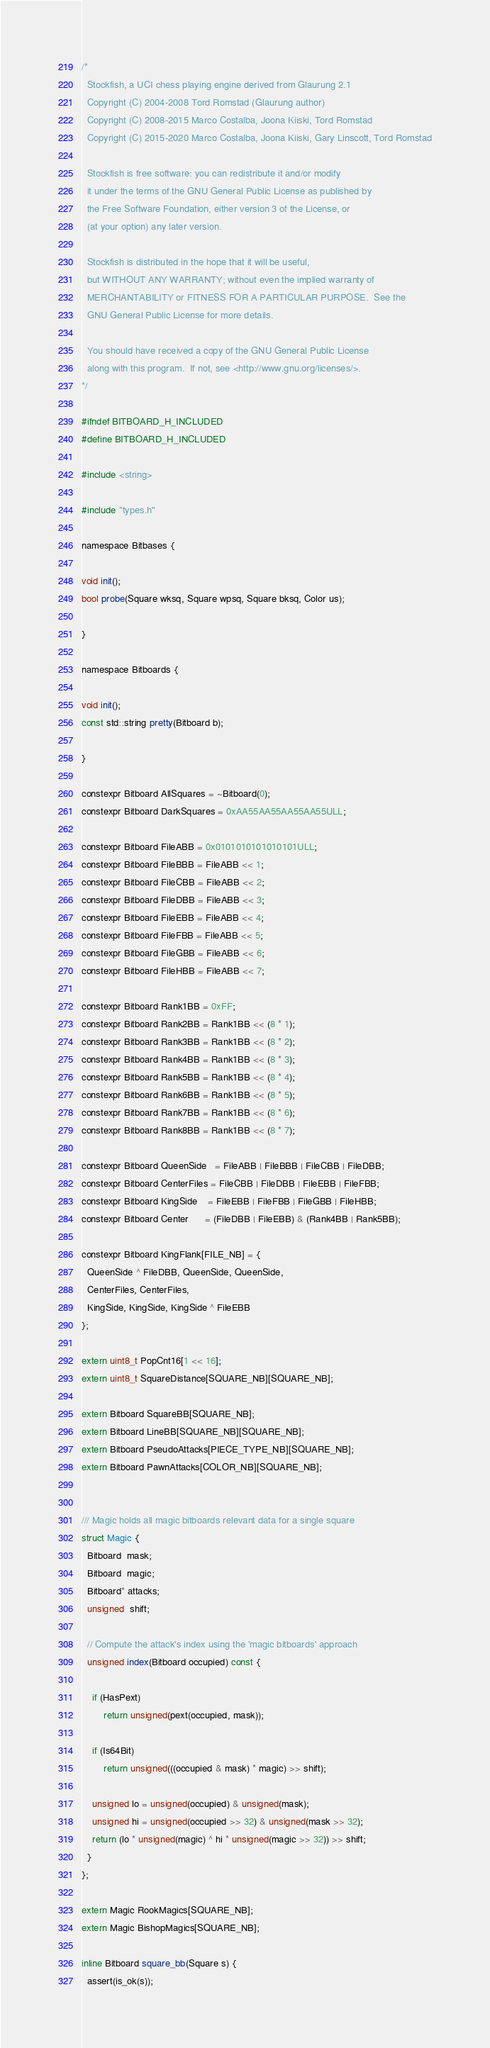Convert code to text. <code><loc_0><loc_0><loc_500><loc_500><_C_>/*
  Stockfish, a UCI chess playing engine derived from Glaurung 2.1
  Copyright (C) 2004-2008 Tord Romstad (Glaurung author)
  Copyright (C) 2008-2015 Marco Costalba, Joona Kiiski, Tord Romstad
  Copyright (C) 2015-2020 Marco Costalba, Joona Kiiski, Gary Linscott, Tord Romstad

  Stockfish is free software: you can redistribute it and/or modify
  it under the terms of the GNU General Public License as published by
  the Free Software Foundation, either version 3 of the License, or
  (at your option) any later version.

  Stockfish is distributed in the hope that it will be useful,
  but WITHOUT ANY WARRANTY; without even the implied warranty of
  MERCHANTABILITY or FITNESS FOR A PARTICULAR PURPOSE.  See the
  GNU General Public License for more details.

  You should have received a copy of the GNU General Public License
  along with this program.  If not, see <http://www.gnu.org/licenses/>.
*/

#ifndef BITBOARD_H_INCLUDED
#define BITBOARD_H_INCLUDED

#include <string>

#include "types.h"

namespace Bitbases {

void init();
bool probe(Square wksq, Square wpsq, Square bksq, Color us);

}

namespace Bitboards {

void init();
const std::string pretty(Bitboard b);

}

constexpr Bitboard AllSquares = ~Bitboard(0);
constexpr Bitboard DarkSquares = 0xAA55AA55AA55AA55ULL;

constexpr Bitboard FileABB = 0x0101010101010101ULL;
constexpr Bitboard FileBBB = FileABB << 1;
constexpr Bitboard FileCBB = FileABB << 2;
constexpr Bitboard FileDBB = FileABB << 3;
constexpr Bitboard FileEBB = FileABB << 4;
constexpr Bitboard FileFBB = FileABB << 5;
constexpr Bitboard FileGBB = FileABB << 6;
constexpr Bitboard FileHBB = FileABB << 7;

constexpr Bitboard Rank1BB = 0xFF;
constexpr Bitboard Rank2BB = Rank1BB << (8 * 1);
constexpr Bitboard Rank3BB = Rank1BB << (8 * 2);
constexpr Bitboard Rank4BB = Rank1BB << (8 * 3);
constexpr Bitboard Rank5BB = Rank1BB << (8 * 4);
constexpr Bitboard Rank6BB = Rank1BB << (8 * 5);
constexpr Bitboard Rank7BB = Rank1BB << (8 * 6);
constexpr Bitboard Rank8BB = Rank1BB << (8 * 7);

constexpr Bitboard QueenSide   = FileABB | FileBBB | FileCBB | FileDBB;
constexpr Bitboard CenterFiles = FileCBB | FileDBB | FileEBB | FileFBB;
constexpr Bitboard KingSide    = FileEBB | FileFBB | FileGBB | FileHBB;
constexpr Bitboard Center      = (FileDBB | FileEBB) & (Rank4BB | Rank5BB);

constexpr Bitboard KingFlank[FILE_NB] = {
  QueenSide ^ FileDBB, QueenSide, QueenSide,
  CenterFiles, CenterFiles,
  KingSide, KingSide, KingSide ^ FileEBB
};

extern uint8_t PopCnt16[1 << 16];
extern uint8_t SquareDistance[SQUARE_NB][SQUARE_NB];

extern Bitboard SquareBB[SQUARE_NB];
extern Bitboard LineBB[SQUARE_NB][SQUARE_NB];
extern Bitboard PseudoAttacks[PIECE_TYPE_NB][SQUARE_NB];
extern Bitboard PawnAttacks[COLOR_NB][SQUARE_NB];


/// Magic holds all magic bitboards relevant data for a single square
struct Magic {
  Bitboard  mask;
  Bitboard  magic;
  Bitboard* attacks;
  unsigned  shift;

  // Compute the attack's index using the 'magic bitboards' approach
  unsigned index(Bitboard occupied) const {

    if (HasPext)
        return unsigned(pext(occupied, mask));

    if (Is64Bit)
        return unsigned(((occupied & mask) * magic) >> shift);

    unsigned lo = unsigned(occupied) & unsigned(mask);
    unsigned hi = unsigned(occupied >> 32) & unsigned(mask >> 32);
    return (lo * unsigned(magic) ^ hi * unsigned(magic >> 32)) >> shift;
  }
};

extern Magic RookMagics[SQUARE_NB];
extern Magic BishopMagics[SQUARE_NB];

inline Bitboard square_bb(Square s) {
  assert(is_ok(s));</code> 